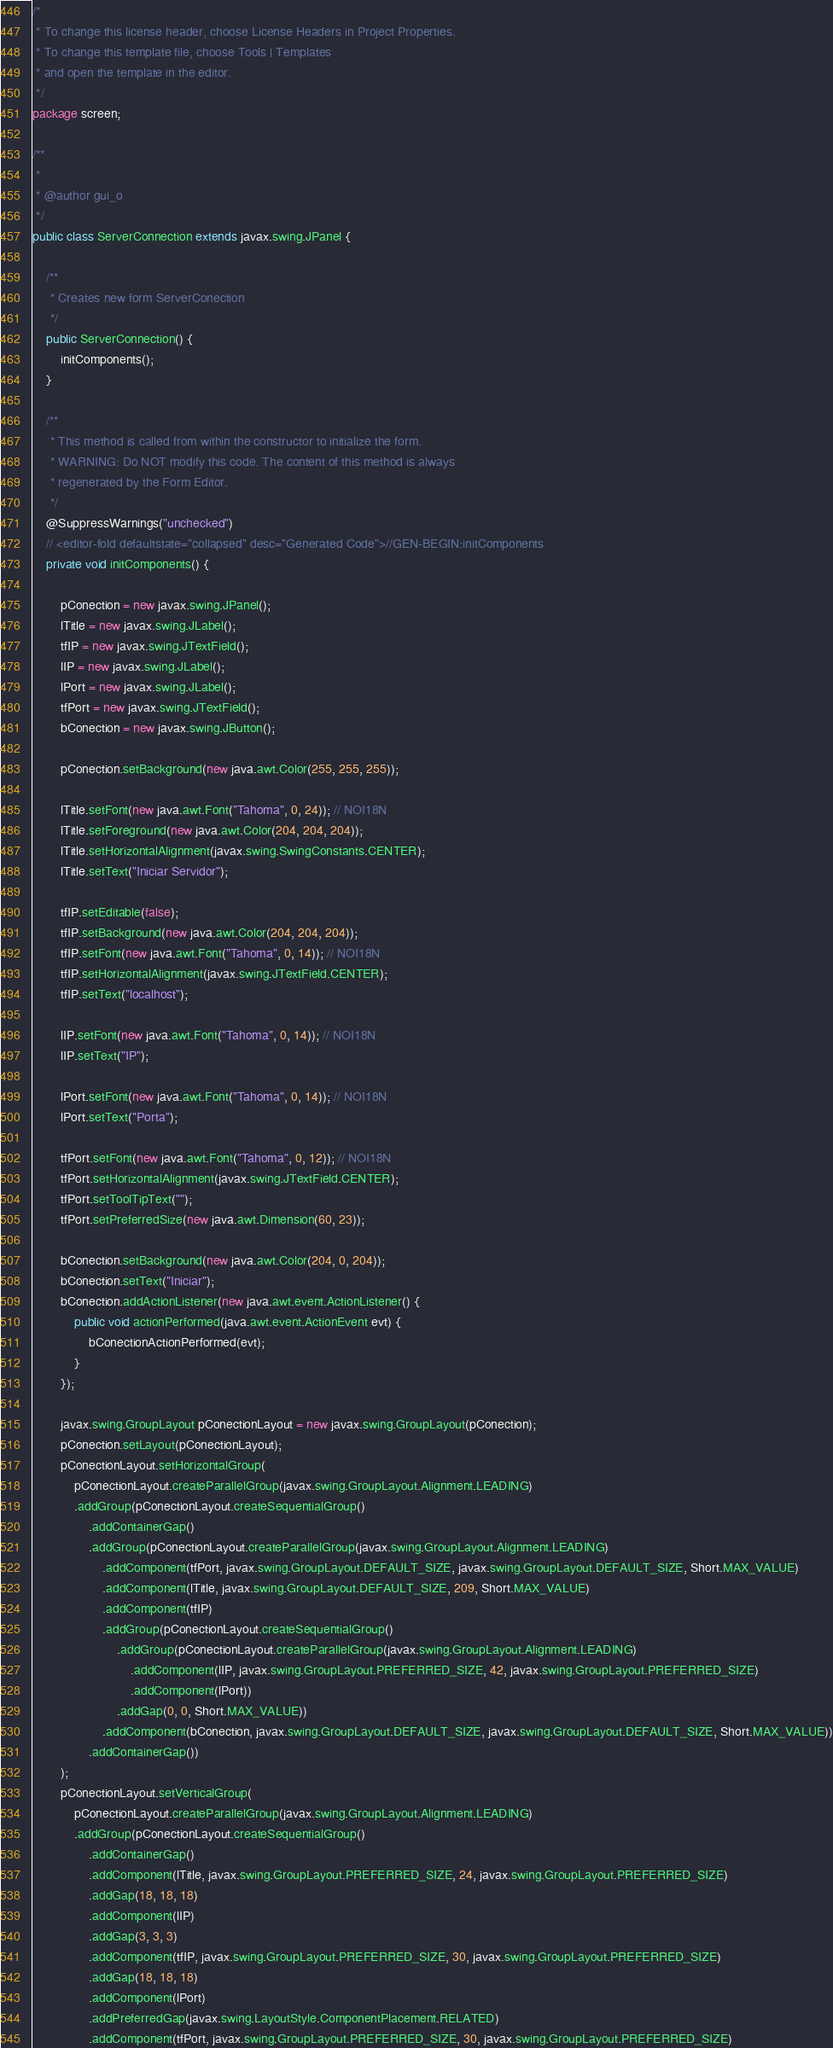<code> <loc_0><loc_0><loc_500><loc_500><_Java_>/*
 * To change this license header, choose License Headers in Project Properties.
 * To change this template file, choose Tools | Templates
 * and open the template in the editor.
 */
package screen;

/**
 *
 * @author gui_o
 */
public class ServerConnection extends javax.swing.JPanel {

    /**
     * Creates new form ServerConection
     */
    public ServerConnection() {
        initComponents();
    }

    /**
     * This method is called from within the constructor to initialize the form.
     * WARNING: Do NOT modify this code. The content of this method is always
     * regenerated by the Form Editor.
     */
    @SuppressWarnings("unchecked")
    // <editor-fold defaultstate="collapsed" desc="Generated Code">//GEN-BEGIN:initComponents
    private void initComponents() {

        pConection = new javax.swing.JPanel();
        lTitle = new javax.swing.JLabel();
        tfIP = new javax.swing.JTextField();
        lIP = new javax.swing.JLabel();
        lPort = new javax.swing.JLabel();
        tfPort = new javax.swing.JTextField();
        bConection = new javax.swing.JButton();

        pConection.setBackground(new java.awt.Color(255, 255, 255));

        lTitle.setFont(new java.awt.Font("Tahoma", 0, 24)); // NOI18N
        lTitle.setForeground(new java.awt.Color(204, 204, 204));
        lTitle.setHorizontalAlignment(javax.swing.SwingConstants.CENTER);
        lTitle.setText("Iniciar Servidor");

        tfIP.setEditable(false);
        tfIP.setBackground(new java.awt.Color(204, 204, 204));
        tfIP.setFont(new java.awt.Font("Tahoma", 0, 14)); // NOI18N
        tfIP.setHorizontalAlignment(javax.swing.JTextField.CENTER);
        tfIP.setText("localhost");

        lIP.setFont(new java.awt.Font("Tahoma", 0, 14)); // NOI18N
        lIP.setText("IP");

        lPort.setFont(new java.awt.Font("Tahoma", 0, 14)); // NOI18N
        lPort.setText("Porta");

        tfPort.setFont(new java.awt.Font("Tahoma", 0, 12)); // NOI18N
        tfPort.setHorizontalAlignment(javax.swing.JTextField.CENTER);
        tfPort.setToolTipText("");
        tfPort.setPreferredSize(new java.awt.Dimension(60, 23));

        bConection.setBackground(new java.awt.Color(204, 0, 204));
        bConection.setText("Iniciar");
        bConection.addActionListener(new java.awt.event.ActionListener() {
            public void actionPerformed(java.awt.event.ActionEvent evt) {
                bConectionActionPerformed(evt);
            }
        });

        javax.swing.GroupLayout pConectionLayout = new javax.swing.GroupLayout(pConection);
        pConection.setLayout(pConectionLayout);
        pConectionLayout.setHorizontalGroup(
            pConectionLayout.createParallelGroup(javax.swing.GroupLayout.Alignment.LEADING)
            .addGroup(pConectionLayout.createSequentialGroup()
                .addContainerGap()
                .addGroup(pConectionLayout.createParallelGroup(javax.swing.GroupLayout.Alignment.LEADING)
                    .addComponent(tfPort, javax.swing.GroupLayout.DEFAULT_SIZE, javax.swing.GroupLayout.DEFAULT_SIZE, Short.MAX_VALUE)
                    .addComponent(lTitle, javax.swing.GroupLayout.DEFAULT_SIZE, 209, Short.MAX_VALUE)
                    .addComponent(tfIP)
                    .addGroup(pConectionLayout.createSequentialGroup()
                        .addGroup(pConectionLayout.createParallelGroup(javax.swing.GroupLayout.Alignment.LEADING)
                            .addComponent(lIP, javax.swing.GroupLayout.PREFERRED_SIZE, 42, javax.swing.GroupLayout.PREFERRED_SIZE)
                            .addComponent(lPort))
                        .addGap(0, 0, Short.MAX_VALUE))
                    .addComponent(bConection, javax.swing.GroupLayout.DEFAULT_SIZE, javax.swing.GroupLayout.DEFAULT_SIZE, Short.MAX_VALUE))
                .addContainerGap())
        );
        pConectionLayout.setVerticalGroup(
            pConectionLayout.createParallelGroup(javax.swing.GroupLayout.Alignment.LEADING)
            .addGroup(pConectionLayout.createSequentialGroup()
                .addContainerGap()
                .addComponent(lTitle, javax.swing.GroupLayout.PREFERRED_SIZE, 24, javax.swing.GroupLayout.PREFERRED_SIZE)
                .addGap(18, 18, 18)
                .addComponent(lIP)
                .addGap(3, 3, 3)
                .addComponent(tfIP, javax.swing.GroupLayout.PREFERRED_SIZE, 30, javax.swing.GroupLayout.PREFERRED_SIZE)
                .addGap(18, 18, 18)
                .addComponent(lPort)
                .addPreferredGap(javax.swing.LayoutStyle.ComponentPlacement.RELATED)
                .addComponent(tfPort, javax.swing.GroupLayout.PREFERRED_SIZE, 30, javax.swing.GroupLayout.PREFERRED_SIZE)</code> 